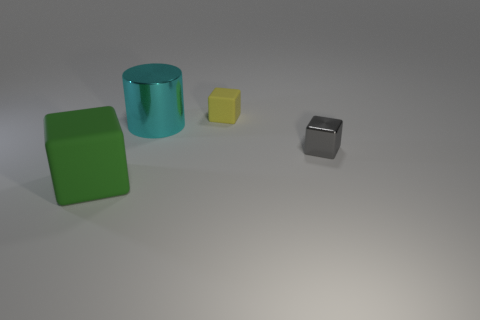How does the lighting in the image affect the appearance of the objects? The lighting in the image creates soft shadows to the right of the objects, suggesting a light source to the top left. It gives the objects dimensionality and helps distinguish their shapes and textures, while the matte finish of the objects prevents any harsh reflections. 